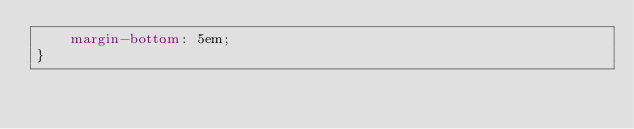<code> <loc_0><loc_0><loc_500><loc_500><_CSS_>    margin-bottom: 5em;
}
</code> 